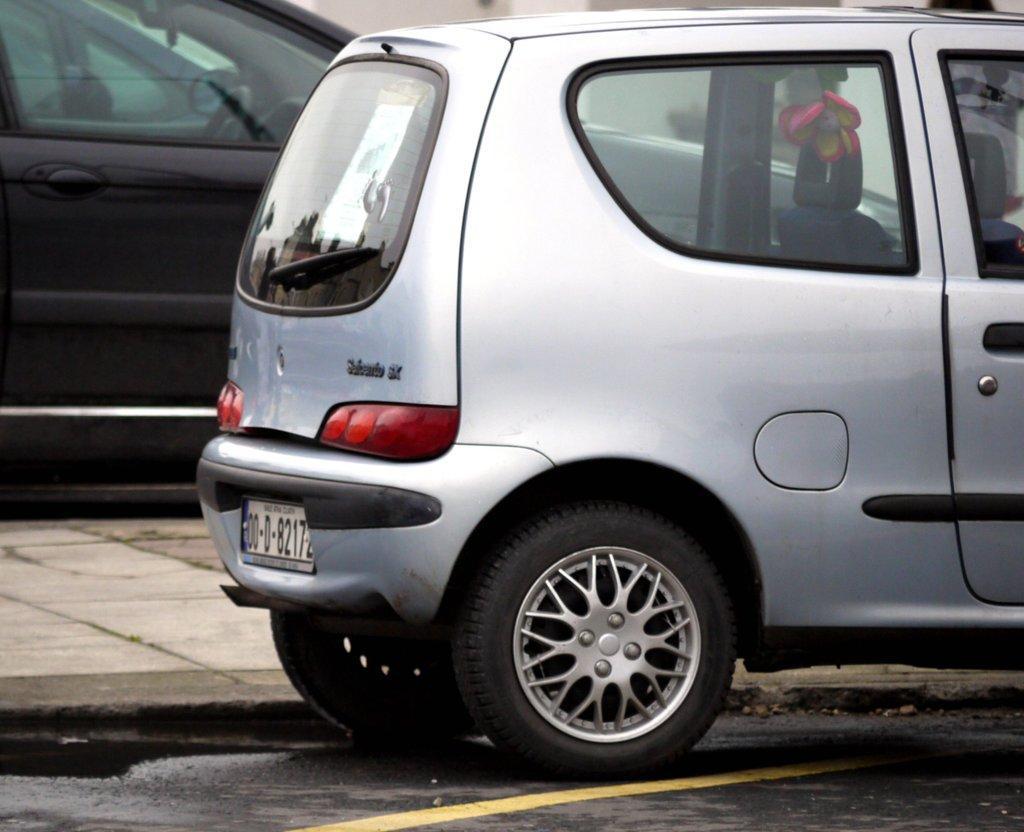Please provide a concise description of this image. In this image I can see there are cars on the road. And there is a sidewalk. And there is a doll in the car. 